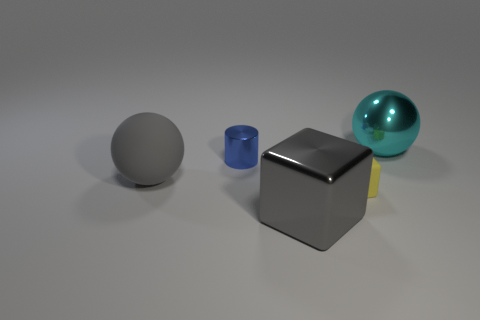Add 2 green cylinders. How many objects exist? 7 Subtract all cyan spheres. How many spheres are left? 1 Add 2 big gray shiny objects. How many big gray shiny objects are left? 3 Add 1 tiny yellow matte objects. How many tiny yellow matte objects exist? 2 Subtract 0 purple balls. How many objects are left? 5 Subtract all cubes. How many objects are left? 3 Subtract all cyan blocks. Subtract all brown cylinders. How many blocks are left? 2 Subtract all green cylinders. Subtract all blue cylinders. How many objects are left? 4 